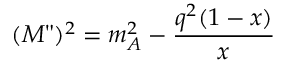<formula> <loc_0><loc_0><loc_500><loc_500>( M " ) ^ { 2 } = m _ { A } ^ { 2 } - \frac { q ^ { 2 } ( 1 - x ) } { x }</formula> 